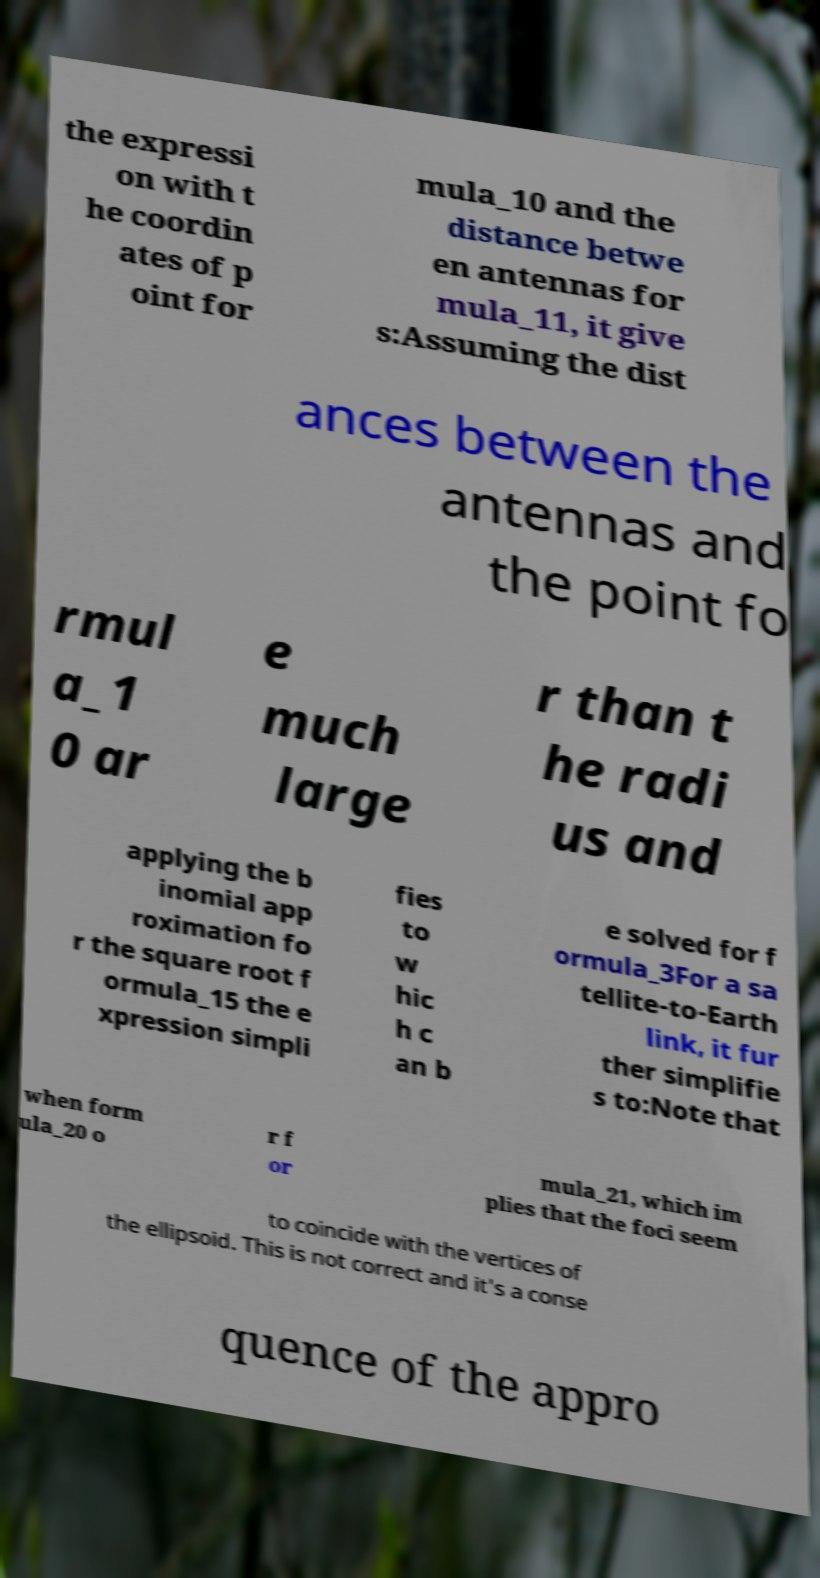There's text embedded in this image that I need extracted. Can you transcribe it verbatim? the expressi on with t he coordin ates of p oint for mula_10 and the distance betwe en antennas for mula_11, it give s:Assuming the dist ances between the antennas and the point fo rmul a_1 0 ar e much large r than t he radi us and applying the b inomial app roximation fo r the square root f ormula_15 the e xpression simpli fies to w hic h c an b e solved for f ormula_3For a sa tellite-to-Earth link, it fur ther simplifie s to:Note that when form ula_20 o r f or mula_21, which im plies that the foci seem to coincide with the vertices of the ellipsoid. This is not correct and it's a conse quence of the appro 